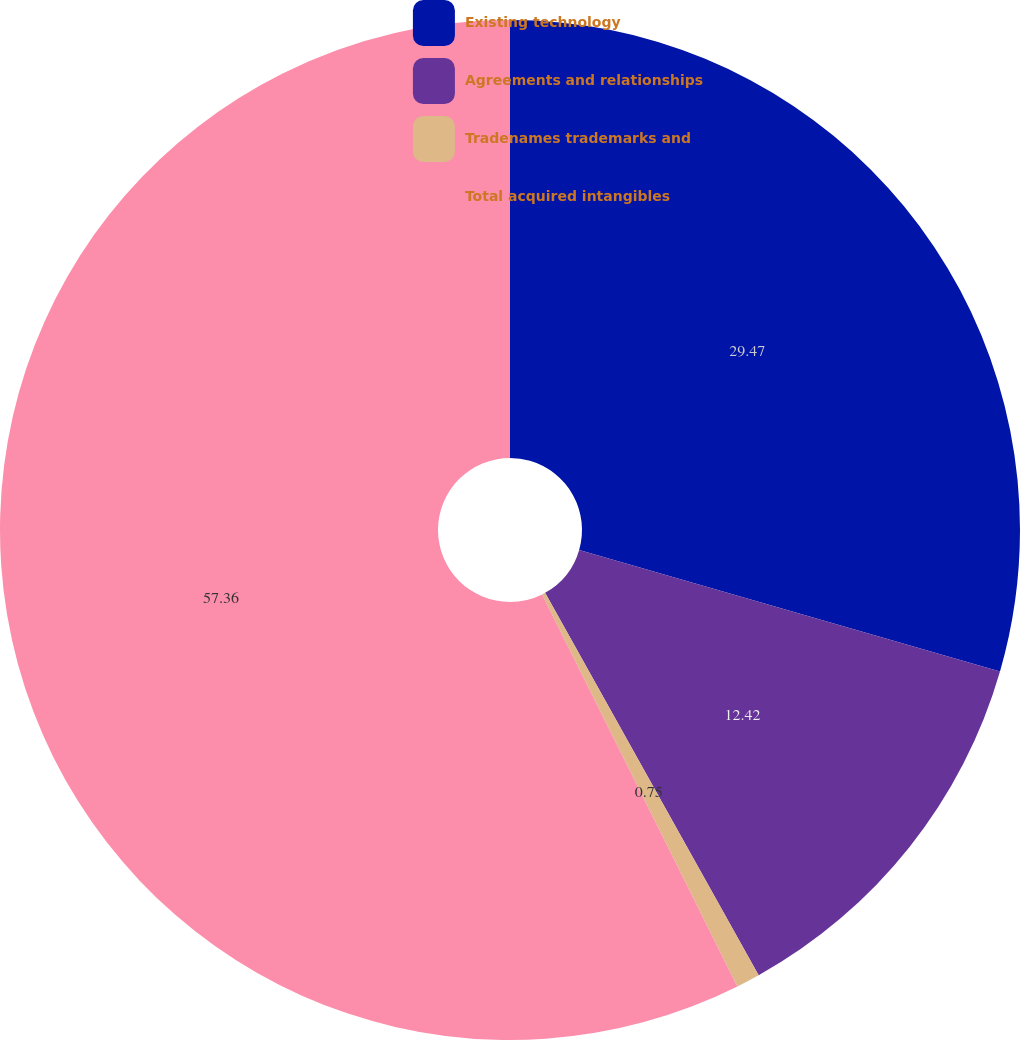<chart> <loc_0><loc_0><loc_500><loc_500><pie_chart><fcel>Existing technology<fcel>Agreements and relationships<fcel>Tradenames trademarks and<fcel>Total acquired intangibles<nl><fcel>29.47%<fcel>12.42%<fcel>0.75%<fcel>57.35%<nl></chart> 